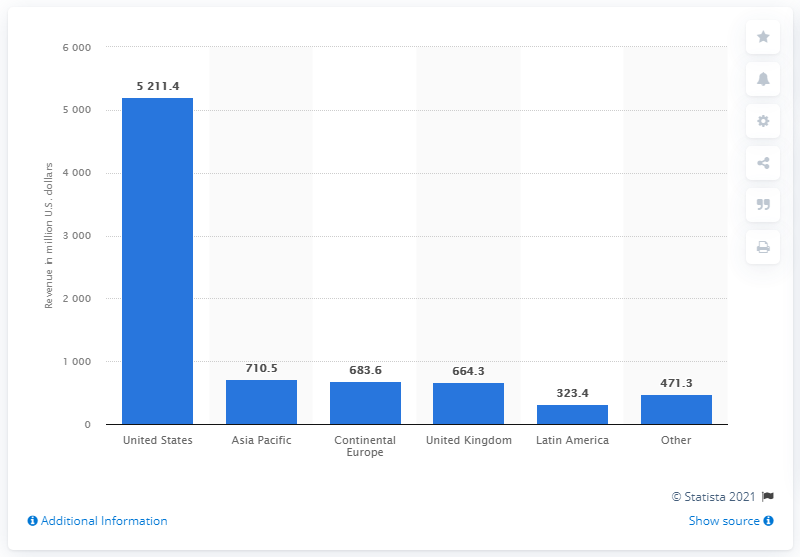Give some essential details in this illustration. Interpublic generates approximately $521.4 million in revenue in the United States. Interpublic Group's second most profitable region is Asia Pacific. 